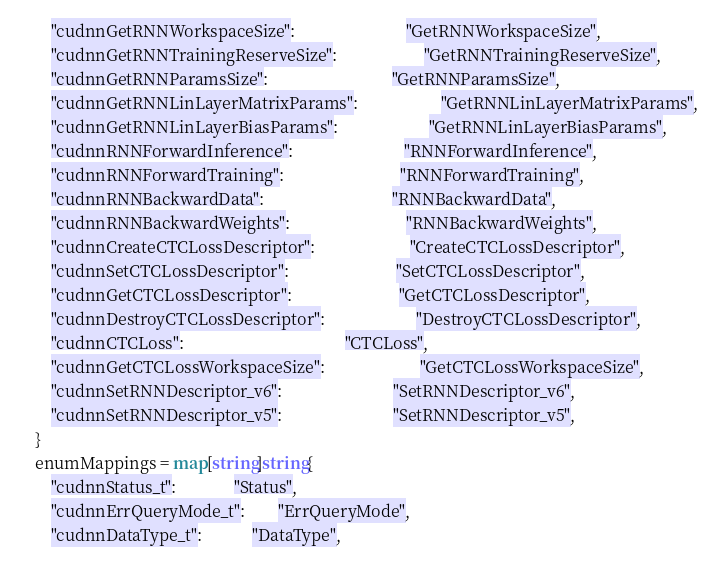Convert code to text. <code><loc_0><loc_0><loc_500><loc_500><_Go_>		"cudnnGetRNNWorkspaceSize":                           "GetRNNWorkspaceSize",
		"cudnnGetRNNTrainingReserveSize":                     "GetRNNTrainingReserveSize",
		"cudnnGetRNNParamsSize":                              "GetRNNParamsSize",
		"cudnnGetRNNLinLayerMatrixParams":                    "GetRNNLinLayerMatrixParams",
		"cudnnGetRNNLinLayerBiasParams":                      "GetRNNLinLayerBiasParams",
		"cudnnRNNForwardInference":                           "RNNForwardInference",
		"cudnnRNNForwardTraining":                            "RNNForwardTraining",
		"cudnnRNNBackwardData":                               "RNNBackwardData",
		"cudnnRNNBackwardWeights":                            "RNNBackwardWeights",
		"cudnnCreateCTCLossDescriptor":                       "CreateCTCLossDescriptor",
		"cudnnSetCTCLossDescriptor":                          "SetCTCLossDescriptor",
		"cudnnGetCTCLossDescriptor":                          "GetCTCLossDescriptor",
		"cudnnDestroyCTCLossDescriptor":                      "DestroyCTCLossDescriptor",
		"cudnnCTCLoss":                                       "CTCLoss",
		"cudnnGetCTCLossWorkspaceSize":                       "GetCTCLossWorkspaceSize",
		"cudnnSetRNNDescriptor_v6":                           "SetRNNDescriptor_v6",
		"cudnnSetRNNDescriptor_v5":                           "SetRNNDescriptor_v5",
	}
	enumMappings = map[string]string{
		"cudnnStatus_t":              "Status",
		"cudnnErrQueryMode_t":        "ErrQueryMode",
		"cudnnDataType_t":            "DataType",</code> 